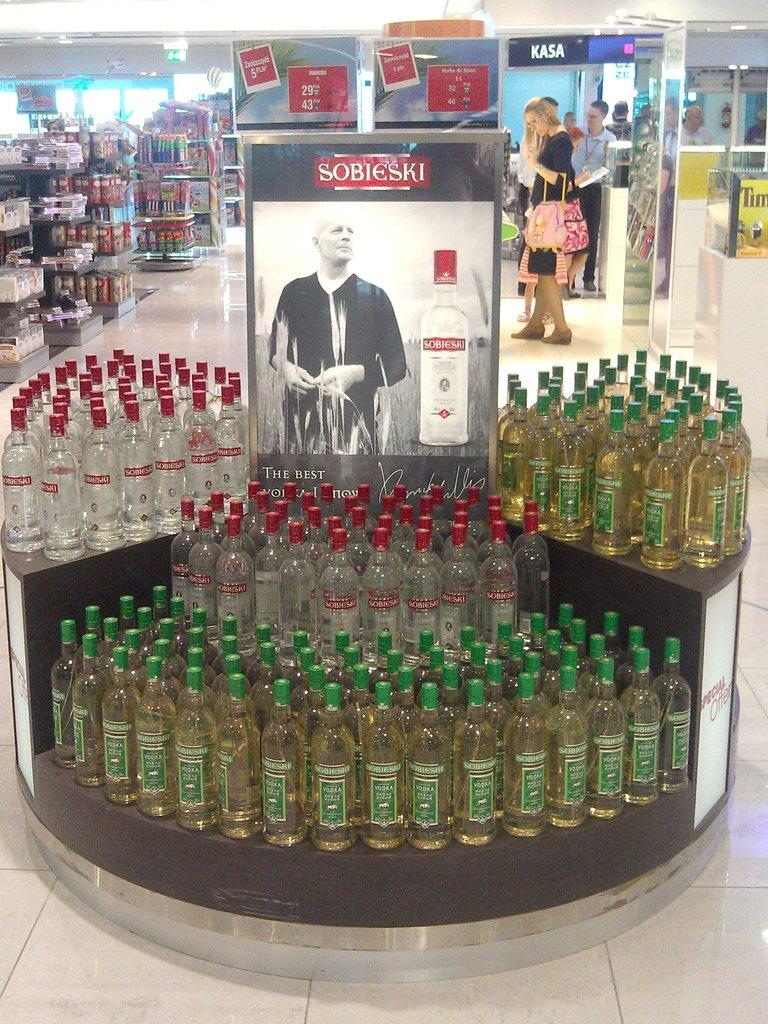<image>
Render a clear and concise summary of the photo. A display of Sobieski bottles sits in a store. 